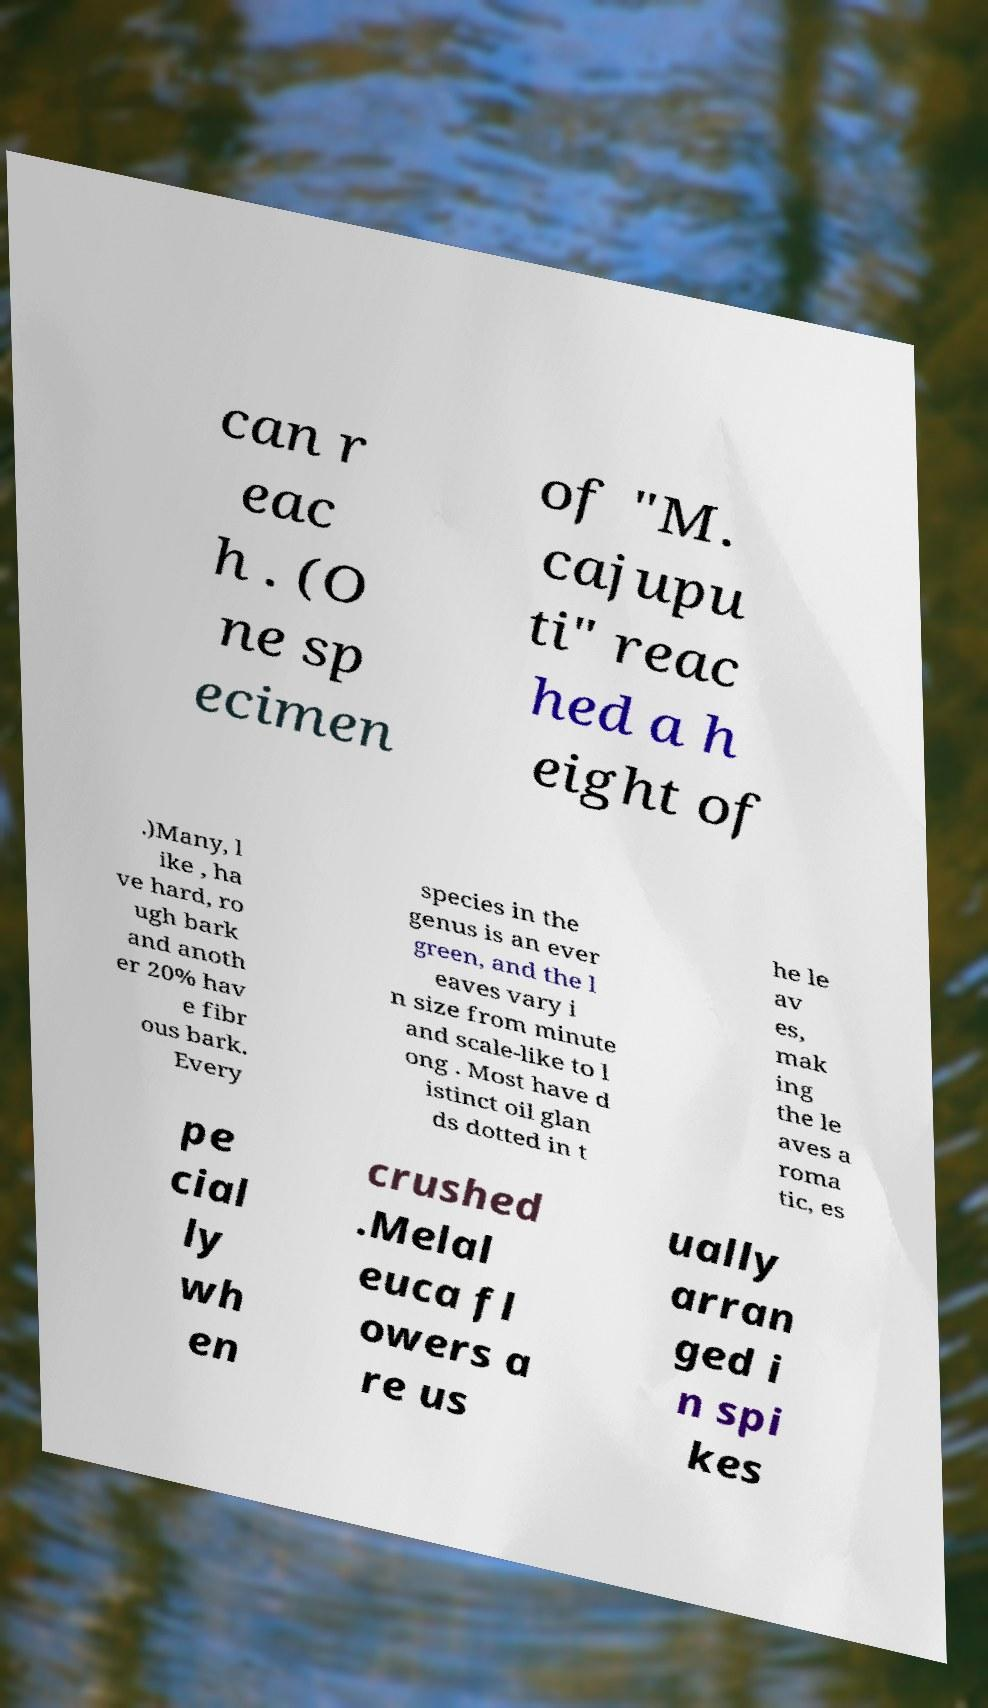What messages or text are displayed in this image? I need them in a readable, typed format. can r eac h . (O ne sp ecimen of "M. cajupu ti" reac hed a h eight of .)Many, l ike , ha ve hard, ro ugh bark and anoth er 20% hav e fibr ous bark. Every species in the genus is an ever green, and the l eaves vary i n size from minute and scale-like to l ong . Most have d istinct oil glan ds dotted in t he le av es, mak ing the le aves a roma tic, es pe cial ly wh en crushed .Melal euca fl owers a re us ually arran ged i n spi kes 